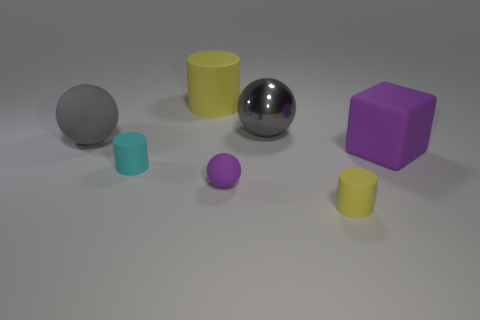Add 1 yellow rubber objects. How many objects exist? 8 Subtract all cylinders. How many objects are left? 4 Subtract 0 gray cylinders. How many objects are left? 7 Subtract all yellow cylinders. Subtract all big gray shiny spheres. How many objects are left? 4 Add 6 gray balls. How many gray balls are left? 8 Add 3 tiny purple things. How many tiny purple things exist? 4 